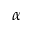Convert formula to latex. <formula><loc_0><loc_0><loc_500><loc_500>\alpha</formula> 